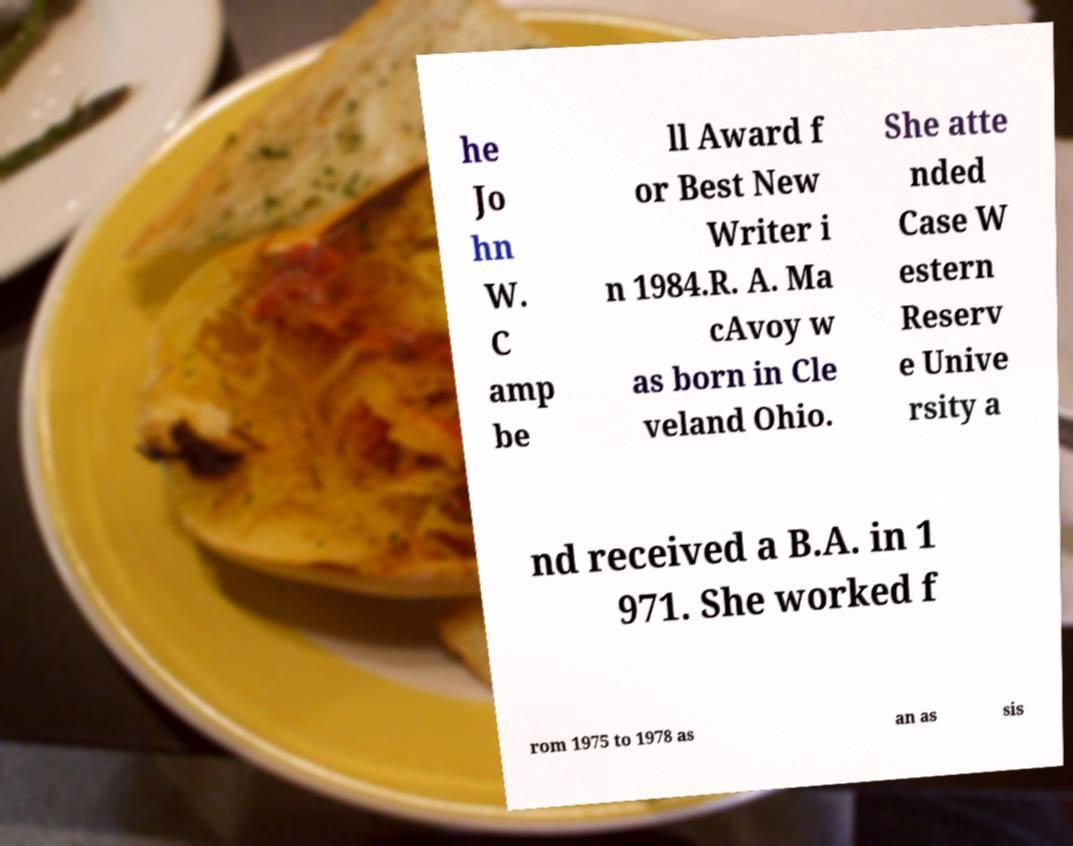Could you assist in decoding the text presented in this image and type it out clearly? he Jo hn W. C amp be ll Award f or Best New Writer i n 1984.R. A. Ma cAvoy w as born in Cle veland Ohio. She atte nded Case W estern Reserv e Unive rsity a nd received a B.A. in 1 971. She worked f rom 1975 to 1978 as an as sis 